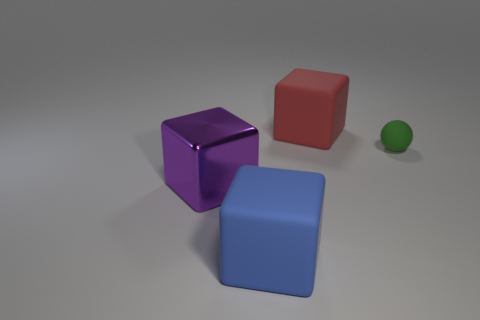Subtract all big red rubber blocks. How many blocks are left? 2 Add 3 small shiny cylinders. How many objects exist? 7 Subtract all blocks. How many objects are left? 1 Subtract all purple blocks. How many blocks are left? 2 Subtract 1 blocks. How many blocks are left? 2 Add 1 large purple blocks. How many large purple blocks are left? 2 Add 4 tiny rubber things. How many tiny rubber things exist? 5 Subtract 0 red cylinders. How many objects are left? 4 Subtract all cyan blocks. Subtract all blue cylinders. How many blocks are left? 3 Subtract all green matte cylinders. Subtract all large purple cubes. How many objects are left? 3 